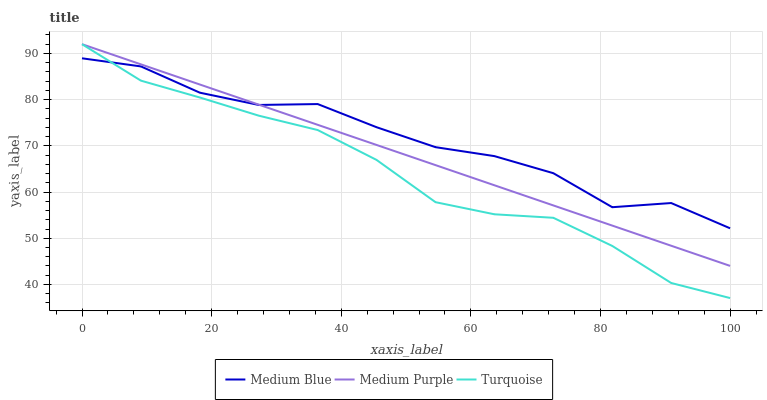Does Turquoise have the minimum area under the curve?
Answer yes or no. Yes. Does Medium Blue have the maximum area under the curve?
Answer yes or no. Yes. Does Medium Blue have the minimum area under the curve?
Answer yes or no. No. Does Turquoise have the maximum area under the curve?
Answer yes or no. No. Is Medium Purple the smoothest?
Answer yes or no. Yes. Is Medium Blue the roughest?
Answer yes or no. Yes. Is Turquoise the smoothest?
Answer yes or no. No. Is Turquoise the roughest?
Answer yes or no. No. Does Turquoise have the lowest value?
Answer yes or no. Yes. Does Medium Blue have the lowest value?
Answer yes or no. No. Does Turquoise have the highest value?
Answer yes or no. Yes. Does Medium Blue have the highest value?
Answer yes or no. No. Does Turquoise intersect Medium Blue?
Answer yes or no. Yes. Is Turquoise less than Medium Blue?
Answer yes or no. No. Is Turquoise greater than Medium Blue?
Answer yes or no. No. 